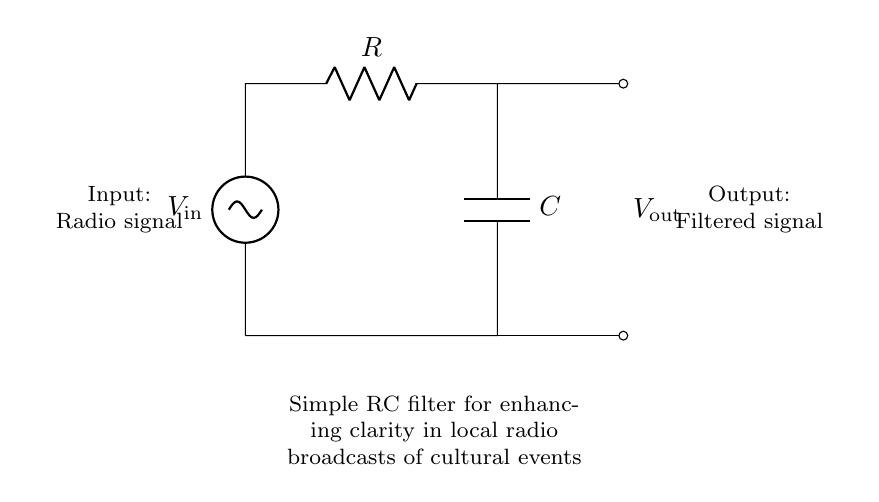What is the function of the resistor in this circuit? The resistor limits the current flowing through the circuit and influences the charging and discharging rate of the capacitor, which is crucial for filtering.
Answer: Limit current What does the capacitor do in this RC filter? The capacitor stores electrical energy and helps filter out unwanted frequencies in the radio signal, allowing only the desired signals to pass through.
Answer: Filter frequencies What is the relationship between input and output in this circuit? The output signal is a filtered version of the input signal; it removes noise and enhances the clarity of the cultural event broadcasts.
Answer: Filtered signal What type of signals does this circuit handle? The circuit is designed to process radio signals, specifically those transmitted during local cultural events.
Answer: Radio signals How does this circuit enhance the clarity of radio broadcasts? By using the RC components to create a low-pass filter, the circuit allows the desired frequencies to pass while attenuating higher frequencies, leading to clearer audio output.
Answer: Low-pass filtering What would happen if the resistor value is increased? Increasing the resistor value would slow down the charging and discharging time of the capacitor, which could affect the frequency response of the circuit and potentially alter the clarity of the output signal.
Answer: Affects frequency response 